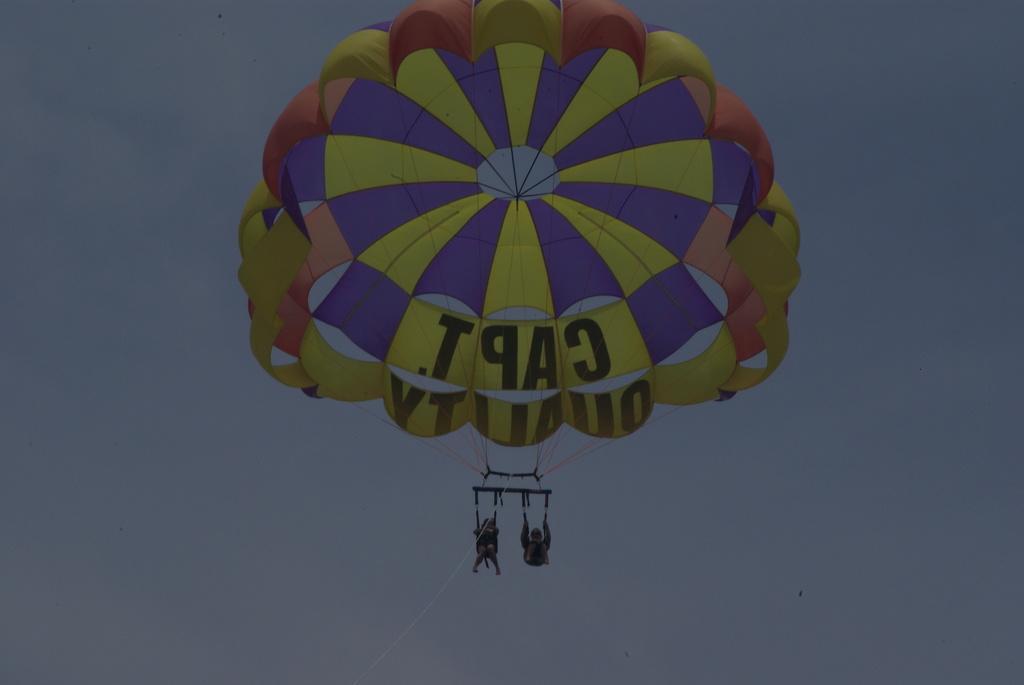Describe this image in one or two sentences. In this image there are two persons diving with a parachute from the sky. 